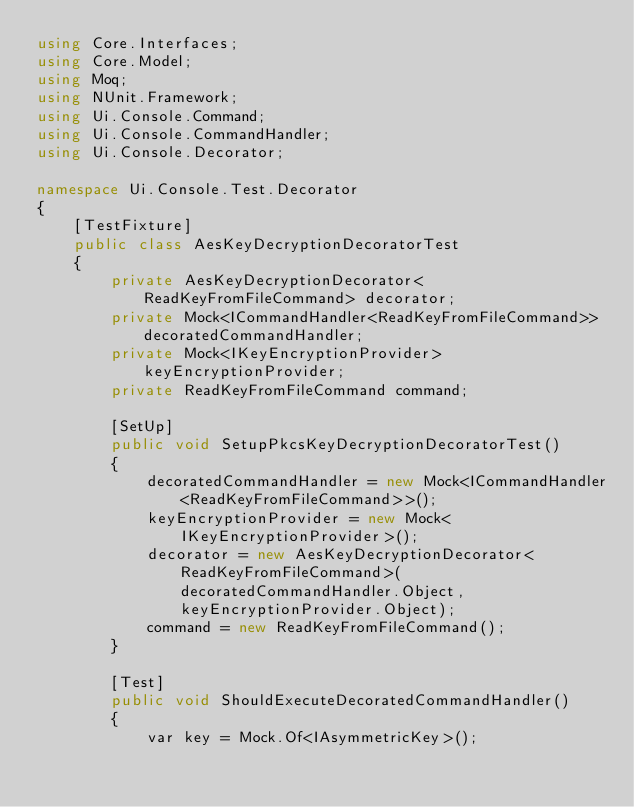<code> <loc_0><loc_0><loc_500><loc_500><_C#_>using Core.Interfaces;
using Core.Model;
using Moq;
using NUnit.Framework;
using Ui.Console.Command;
using Ui.Console.CommandHandler;
using Ui.Console.Decorator;

namespace Ui.Console.Test.Decorator
{
    [TestFixture]
    public class AesKeyDecryptionDecoratorTest
    {
        private AesKeyDecryptionDecorator<ReadKeyFromFileCommand> decorator;
        private Mock<ICommandHandler<ReadKeyFromFileCommand>> decoratedCommandHandler;
        private Mock<IKeyEncryptionProvider> keyEncryptionProvider;
        private ReadKeyFromFileCommand command;

        [SetUp]
        public void SetupPkcsKeyDecryptionDecoratorTest()
        {
            decoratedCommandHandler = new Mock<ICommandHandler<ReadKeyFromFileCommand>>();
            keyEncryptionProvider = new Mock<IKeyEncryptionProvider>();
            decorator = new AesKeyDecryptionDecorator<ReadKeyFromFileCommand>(decoratedCommandHandler.Object, keyEncryptionProvider.Object);
            command = new ReadKeyFromFileCommand();
        }

        [Test]
        public void ShouldExecuteDecoratedCommandHandler()
        {
            var key = Mock.Of<IAsymmetricKey>();</code> 